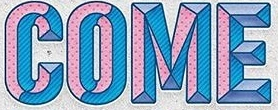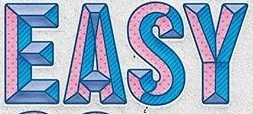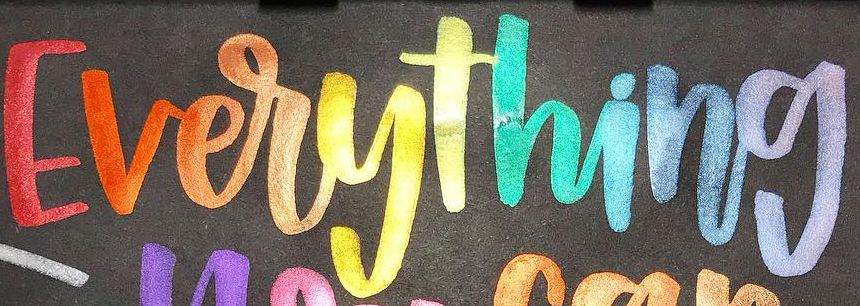Read the text content from these images in order, separated by a semicolon. COME; EASY; Everything 